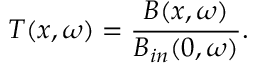<formula> <loc_0><loc_0><loc_500><loc_500>T ( x , \omega ) = \frac { B ( x , \omega ) } { B _ { i n } ( 0 , \omega ) } .</formula> 